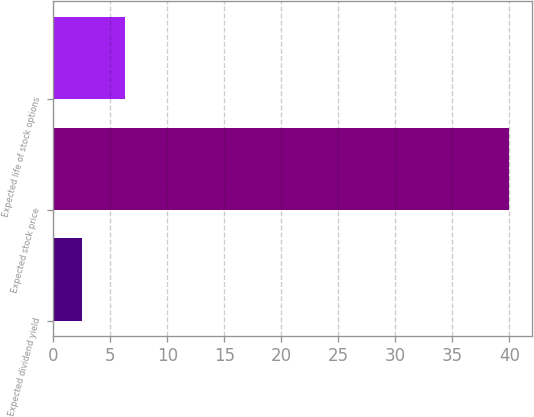Convert chart. <chart><loc_0><loc_0><loc_500><loc_500><bar_chart><fcel>Expected dividend yield<fcel>Expected stock price<fcel>Expected life of stock options<nl><fcel>2.5<fcel>40<fcel>6.25<nl></chart> 